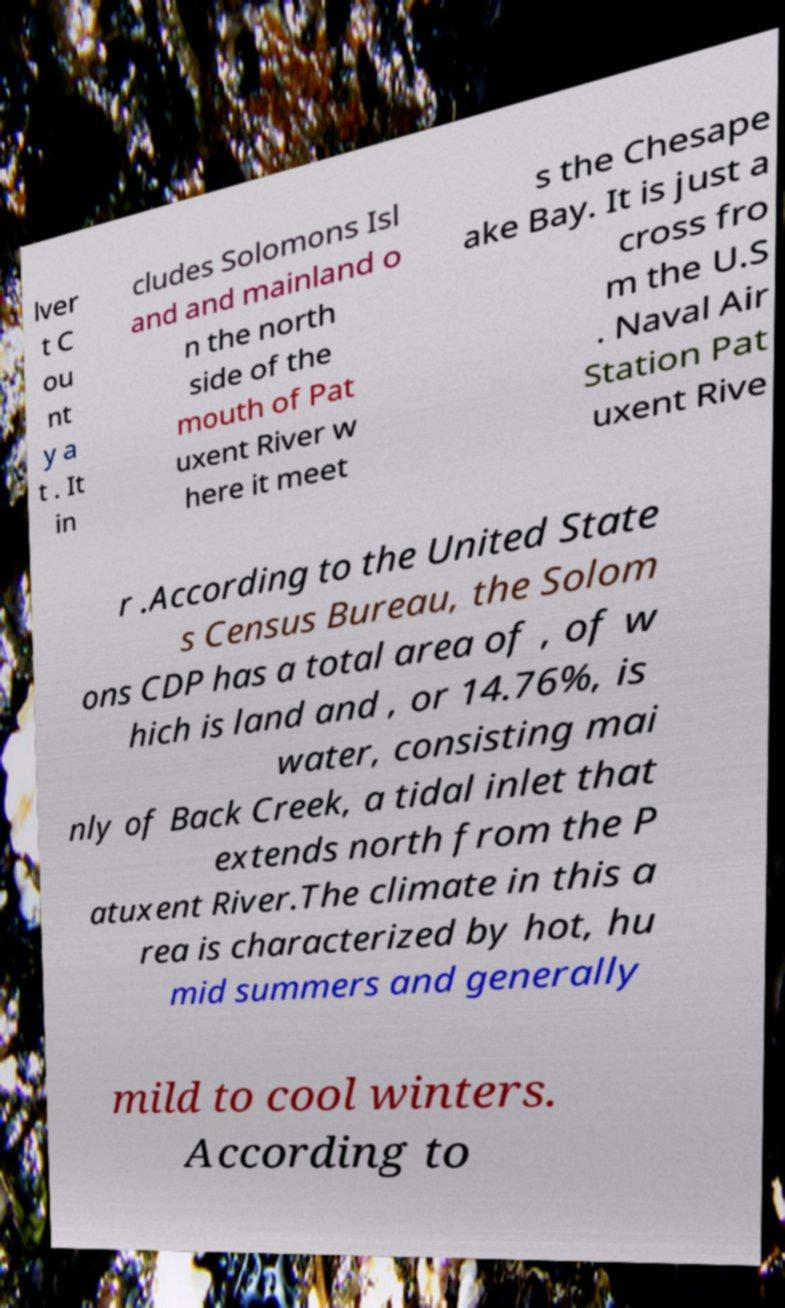Can you accurately transcribe the text from the provided image for me? lver t C ou nt y a t . It in cludes Solomons Isl and and mainland o n the north side of the mouth of Pat uxent River w here it meet s the Chesape ake Bay. It is just a cross fro m the U.S . Naval Air Station Pat uxent Rive r .According to the United State s Census Bureau, the Solom ons CDP has a total area of , of w hich is land and , or 14.76%, is water, consisting mai nly of Back Creek, a tidal inlet that extends north from the P atuxent River.The climate in this a rea is characterized by hot, hu mid summers and generally mild to cool winters. According to 